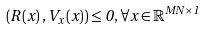Convert formula to latex. <formula><loc_0><loc_0><loc_500><loc_500>\left ( R \left ( x \right ) , V _ { x } \left ( x \right ) \right ) \leq 0 , \forall x \in \mathbb { R } ^ { M N \times 1 }</formula> 